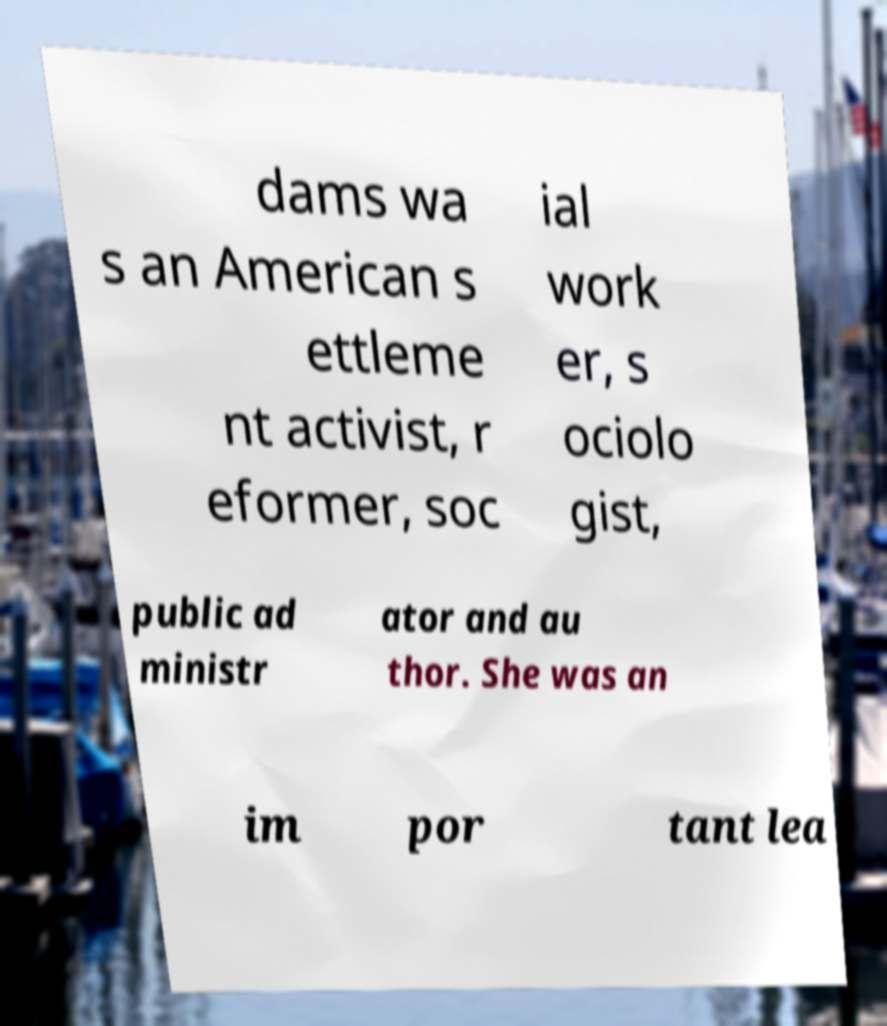Could you extract and type out the text from this image? dams wa s an American s ettleme nt activist, r eformer, soc ial work er, s ociolo gist, public ad ministr ator and au thor. She was an im por tant lea 